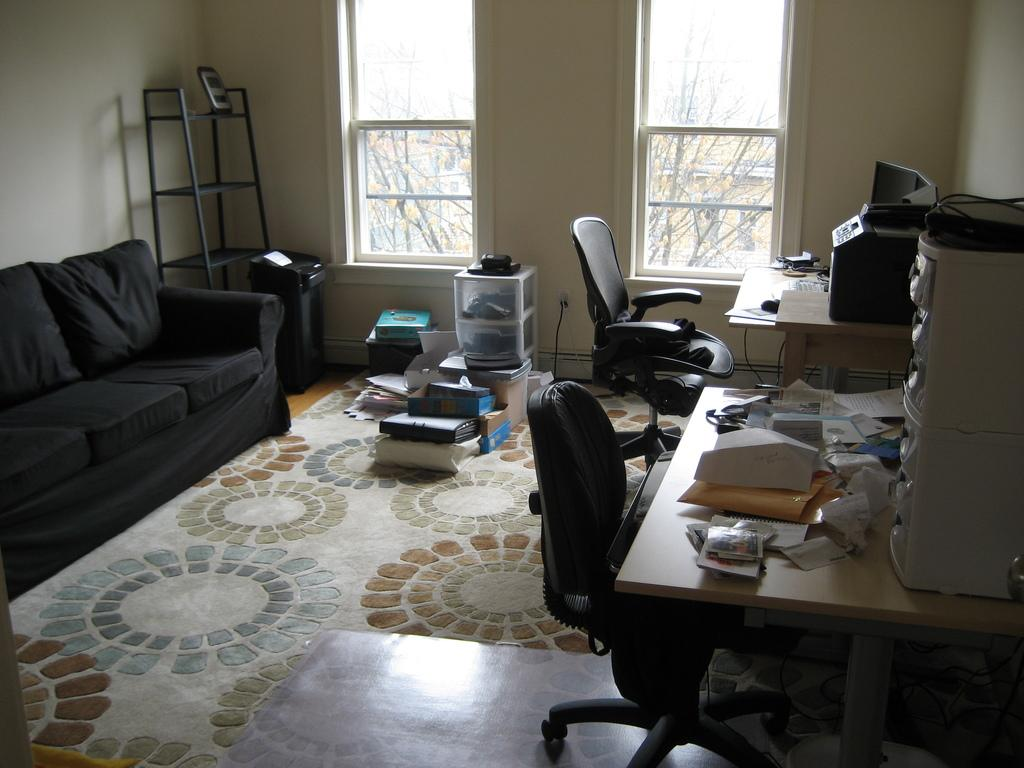What type of furniture is present in the image? There is a table, 2 chairs, and a couch in the image. Where is the couch located in the image? The couch is in the left corner of the image. What can be seen in the background of the image? There is a wall and 2 windows in the image. Are there any other objects visible in the background? Yes, there are some objects visible in the background of the image. What is the rate of the ray's movement in the image? There is no ray present in the image, so it is not possible to determine its movement or rate. 